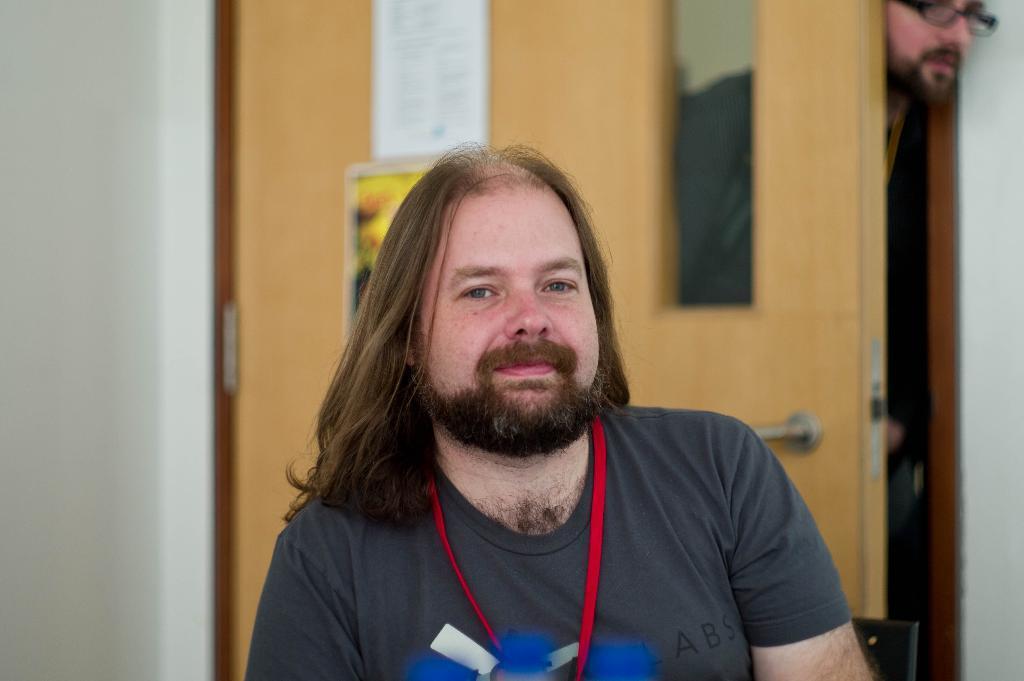Can you describe this image briefly? In this image I can see a man and I can see he is wearing grey colour t shirt. I can also see red colour thing around his neck. Here I can see few blue colour things and in the background can see a door, few posters and a man. I can also see this image is little bit blurry from background. 